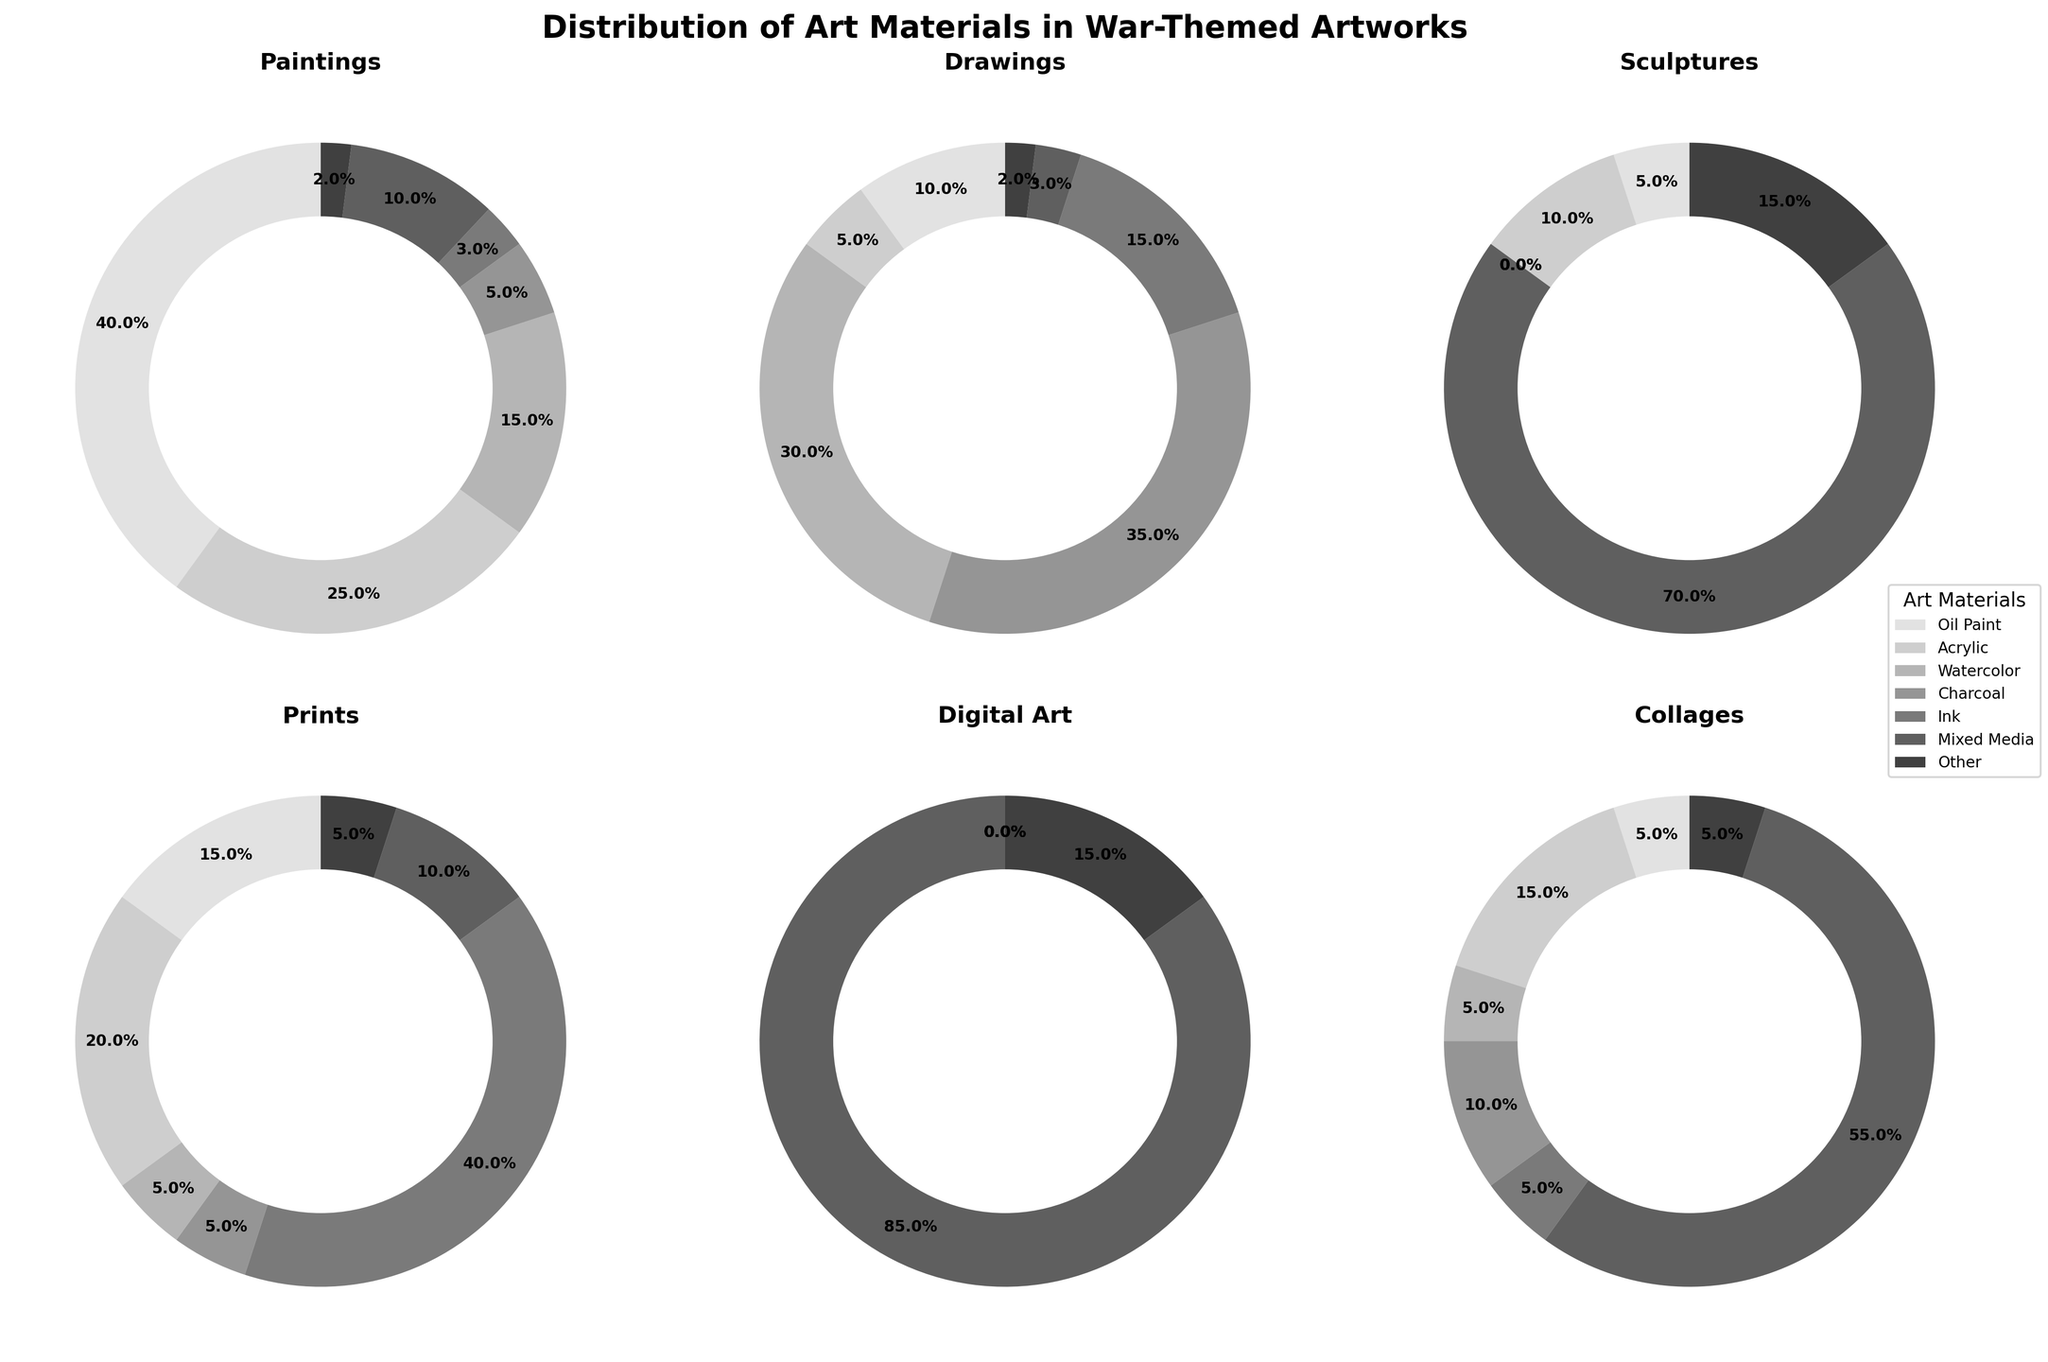Which medium uses oil paint the most? By looking at the six subplots, the oil paint segments are largest in Paintings.
Answer: Paintings Which art form has the highest usage of mixed media? Comparing the size of mixed media segments among all art forms, Installations have the highest with 90%.
Answer: Installations What percentage of Drawings are created with Charcoal and Ink combined? Charcoal has 35% and Ink has 15% in Drawings. Combining these, 35 + 15 = 50%.
Answer: 50% Which two materials are used equally in Prints? By examining the segments for Prints, Watercolor and Charcoal both have 5%.
Answer: Watercolor and Charcoal Is Acrylic more commonly used in Paintings or Sculptures? In Paintings, Acrylic is 25%. In Sculptures, it is 10%. 25% is greater than 10%, so it is more common in Paintings.
Answer: Paintings What is the total percentage of both Watercolor and Charcoal in Collages? For Collages, Watercolor is 5% and Charcoal is 10%. Adding these together gives 5 + 10 = 15%.
Answer: 15% How does the usage of Ink in Drawings compare to its usage in Prints? Ink is used 15% in Drawings and 40% in Prints. Since 40% is greater than 15%, Ink is used more in Prints.
Answer: More in Prints What is the difference in percentage usage of Other materials between Sculptures and Digital Art? Other materials in Sculptures is 15%, and in Digital Art, it is also 15%. The difference is 15 - 15 = 0%.
Answer: 0% Which medium uses the least amount of Charcoal? Comparing Charcoal segments, Sculptures do not use any Charcoal (0%).
Answer: Sculptures 